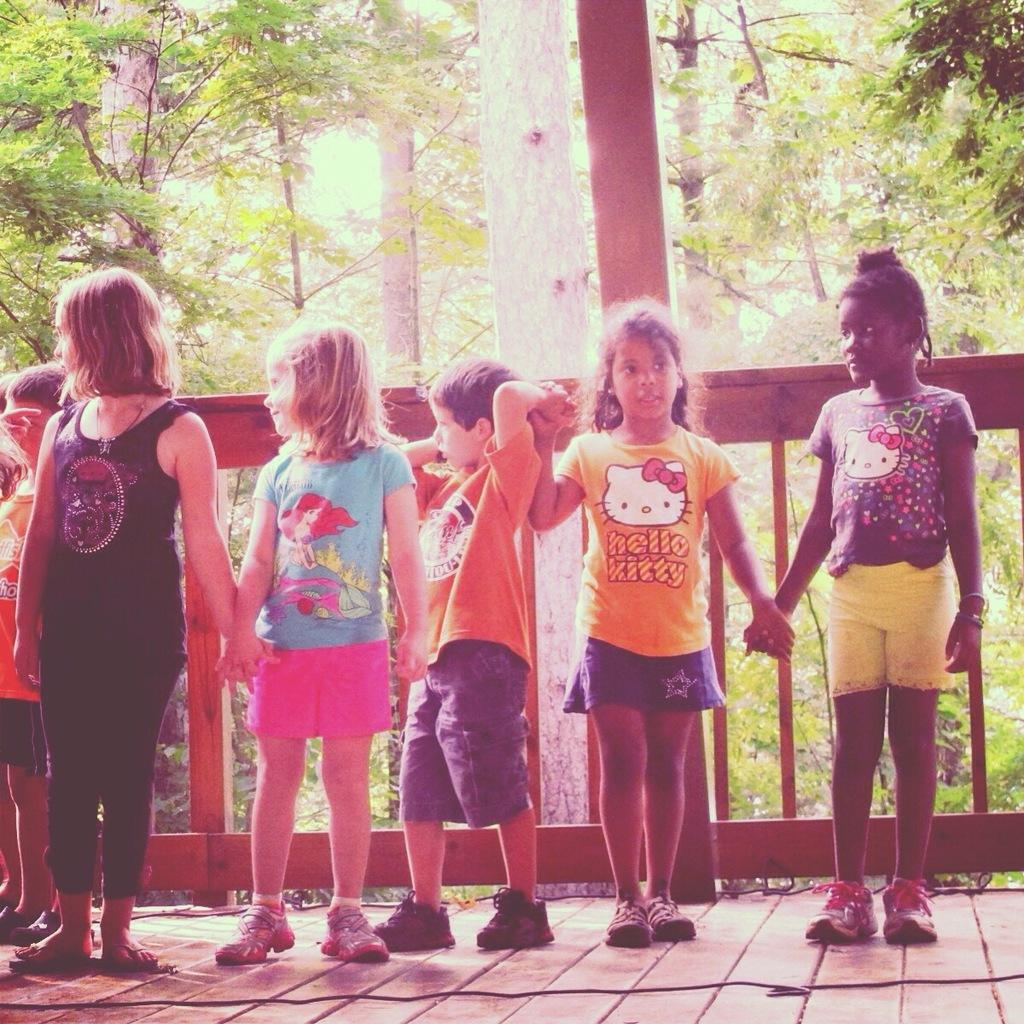What are the kids doing in the image? The kids are standing on the floor and holding hands. What is on the floor besides the kids? There is a cable on the floor. What can be seen in the background of the image? There is a fence, trees, and the sky visible in the background of the image. What type of paste is being used by the beast in the image? There is no beast or paste present in the image. What is the thing that the kids are trying to catch in the image? There is no indication of the kids trying to catch anything in the image. 